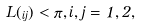Convert formula to latex. <formula><loc_0><loc_0><loc_500><loc_500>L ( \Gamma _ { i j } ) < \pi , i , j = 1 , 2 ,</formula> 